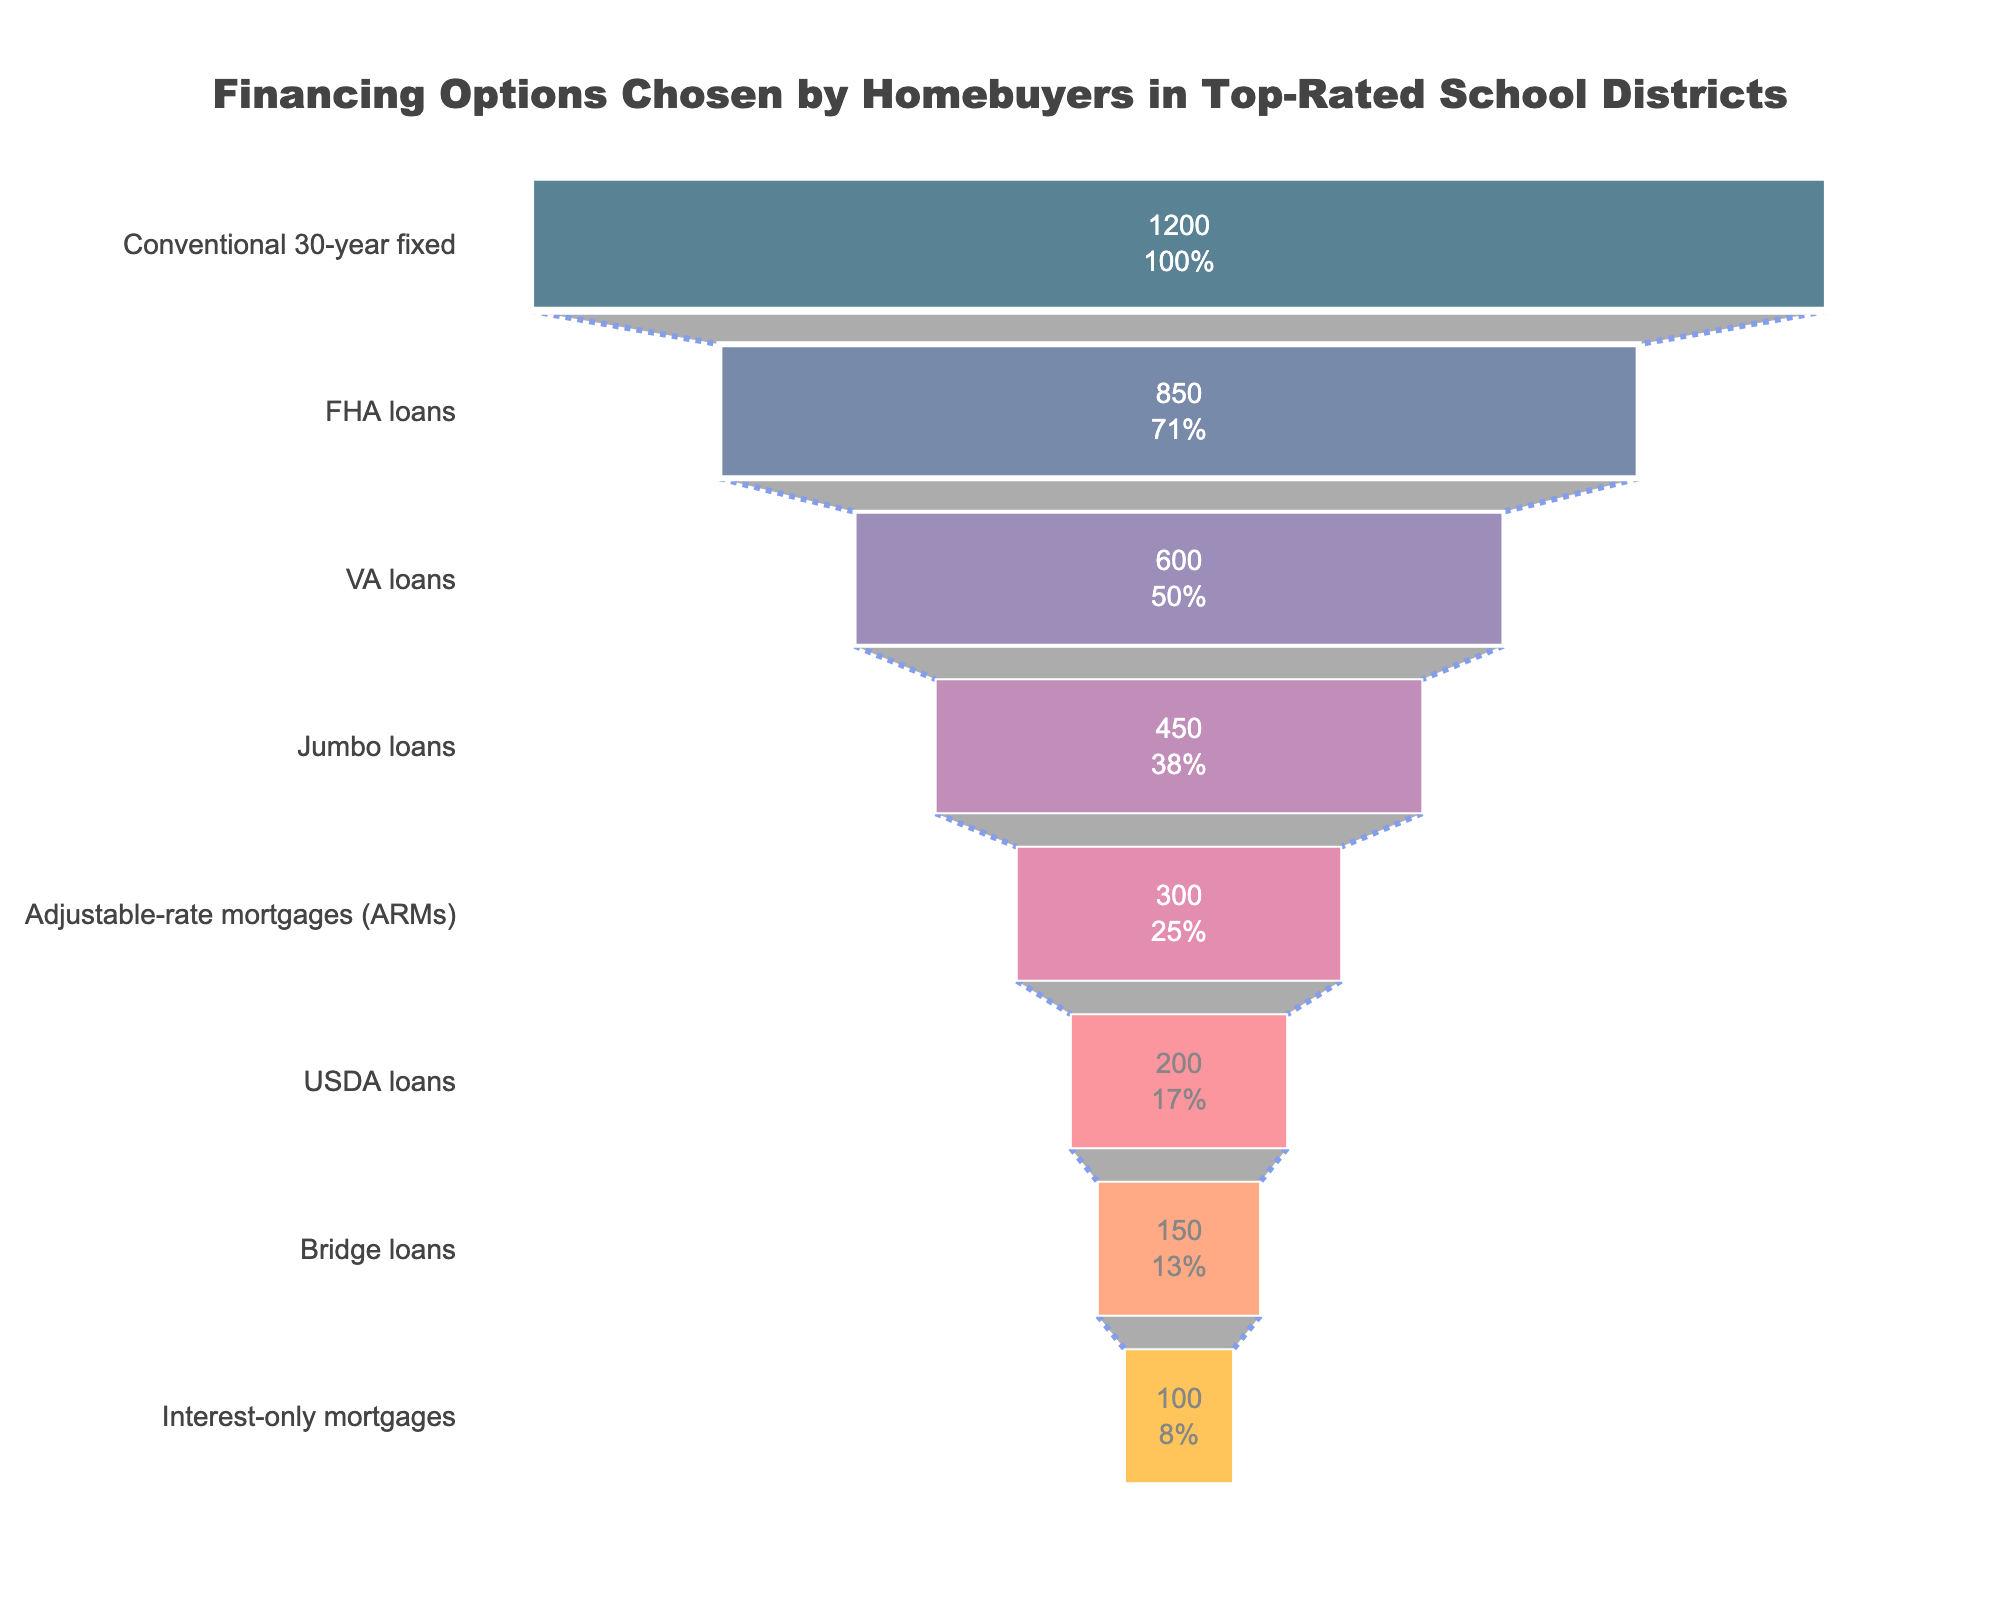What is the title of the figure? The title is visible at the top of the figure, it states the main subject of the chart.
Answer: Financing Options Chosen by Homebuyers in Top-Rated School Districts Which financing option has the highest number of homebuyers? The financing option with the longest bar at the top of the funnel chart represents the one chosen by the most homebuyers.
Answer: Conventional 30-year fixed How many homebuyers chose FHA loans? Look for the FHA loans bar and read the number inside it.
Answer: 850 Which two financing options have the closest number of homebuyers? Compare the lengths of the bars and find those that are closest in size numerically.
Answer: Bridge loans and USDA loans What percentage of homebuyers chose VA loans out of the total? Find the VA loans in the chart and look at the percentage text within its bar.
Answer: Approximately 20% Which financing option is least popular among homebuyers? The shortest bar at the bottom of the funnel chart represents the least chosen financing option.
Answer: Interest-only mortgages What is the difference in the number of homebuyers between Jumbo loans and Adjustable-rate mortgages (ARMs)? Subtract the number of homebuyers who chose ARMs from those who chose Jumbo loans.
Answer: 150 How many homebuyers in total chose USDA loans and Bridge loans combined? Add the number of homebuyers for USDA loans and Bridge loans together.
Answer: 350 What is the rank of Adjustable-rate mortgages (ARMs) in terms of popularity? Look at the position of ARMs in the funnel, counting from the top to determine its rank.
Answer: 5th How many homebuyers opted for financing options other than Conventional 30-year fixed and FHA loans? Subtract the sum of homebuyers for these two financing options from the total number of homebuyers.
Answer: 1800 